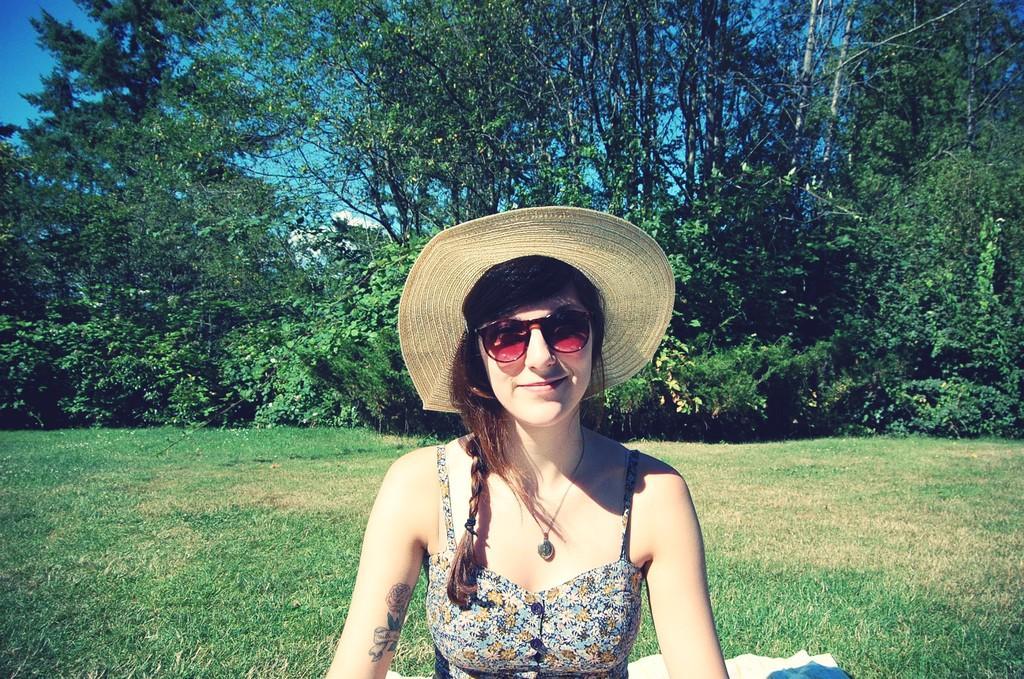Describe this image in one or two sentences. In this image in front there is a girl sitting on the surface of the grass. In the background there are trees and sky. 